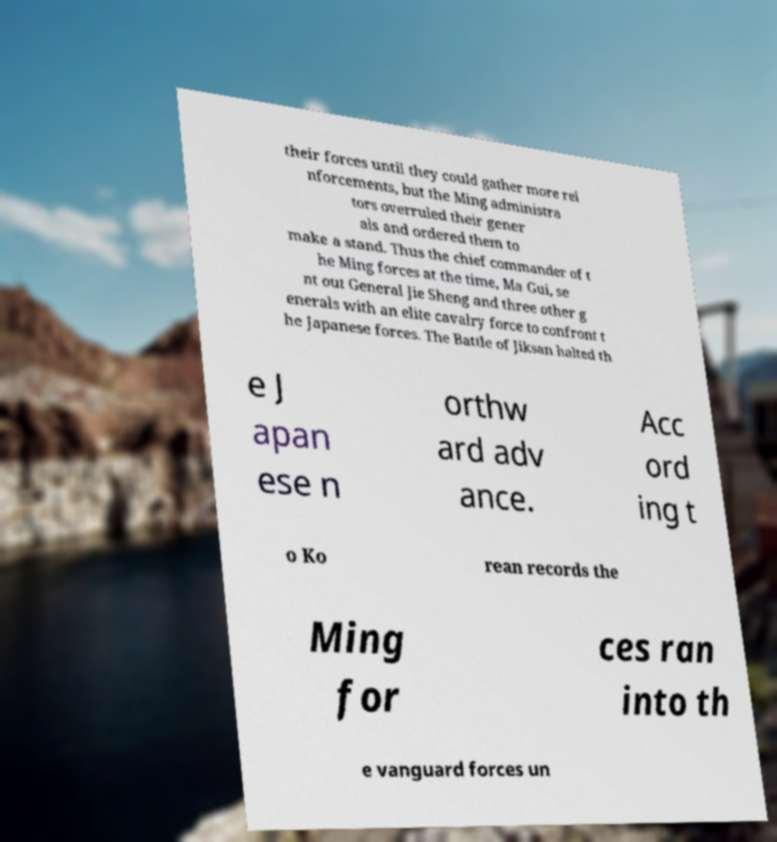For documentation purposes, I need the text within this image transcribed. Could you provide that? their forces until they could gather more rei nforcements, but the Ming administra tors overruled their gener als and ordered them to make a stand. Thus the chief commander of t he Ming forces at the time, Ma Gui, se nt out General Jie Sheng and three other g enerals with an elite cavalry force to confront t he Japanese forces. The Battle of Jiksan halted th e J apan ese n orthw ard adv ance. Acc ord ing t o Ko rean records the Ming for ces ran into th e vanguard forces un 